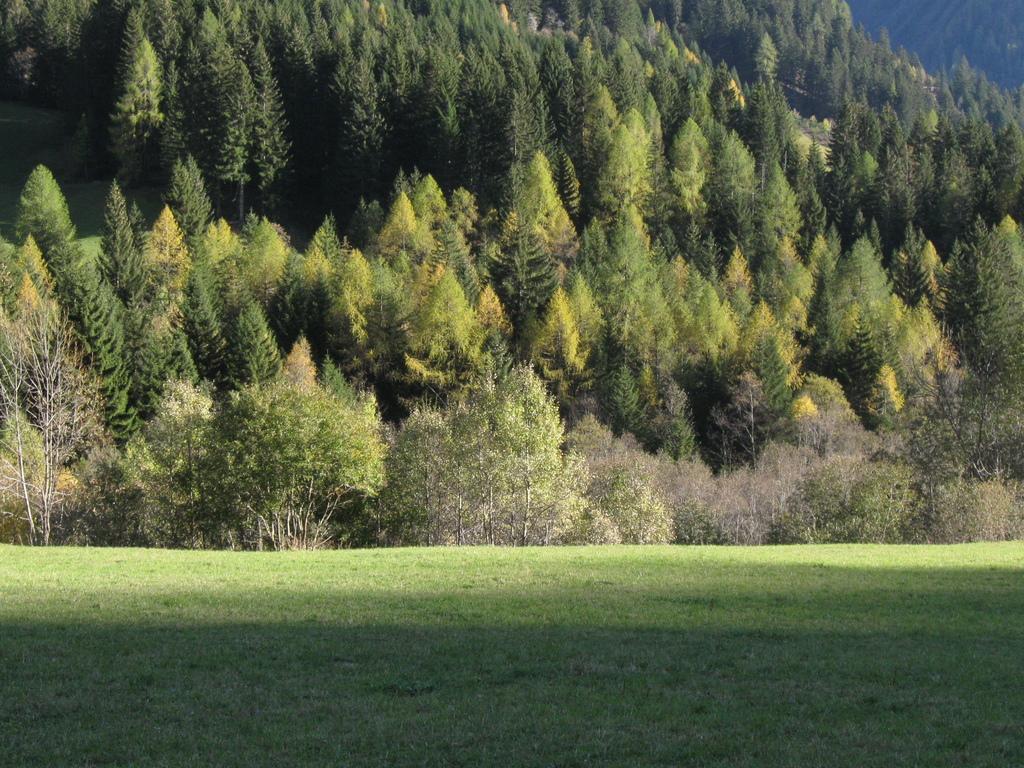Describe this image in one or two sentences. In this image to the bottom there is grass, and in the background there are some trees and plants. 